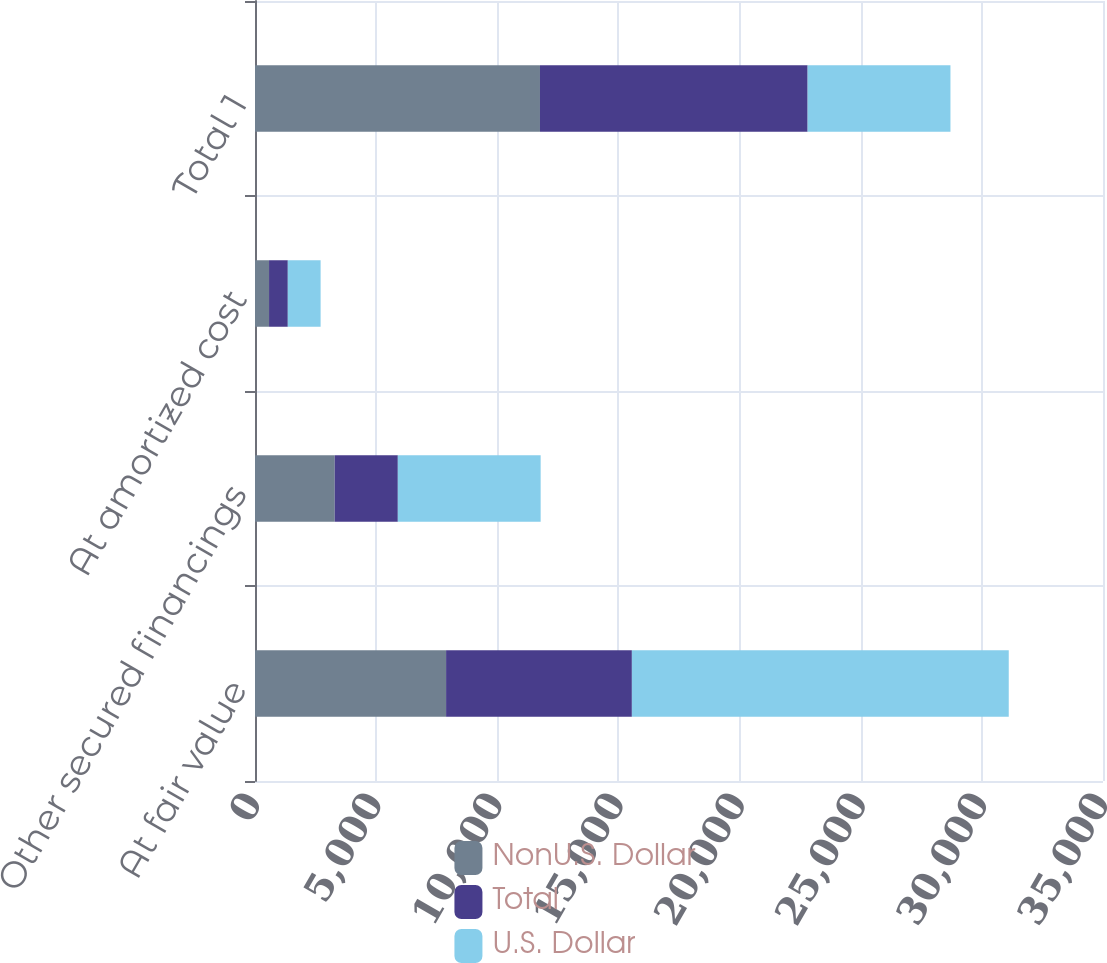Convert chart. <chart><loc_0><loc_0><loc_500><loc_500><stacked_bar_chart><ecel><fcel>At fair value<fcel>Other secured financings<fcel>At amortized cost<fcel>Total 1<nl><fcel>NonU.S. Dollar<fcel>7887<fcel>3290<fcel>580<fcel>11762<nl><fcel>Total<fcel>7668<fcel>2605<fcel>774<fcel>11047<nl><fcel>U.S. Dollar<fcel>15555<fcel>5895<fcel>1354<fcel>5895<nl></chart> 